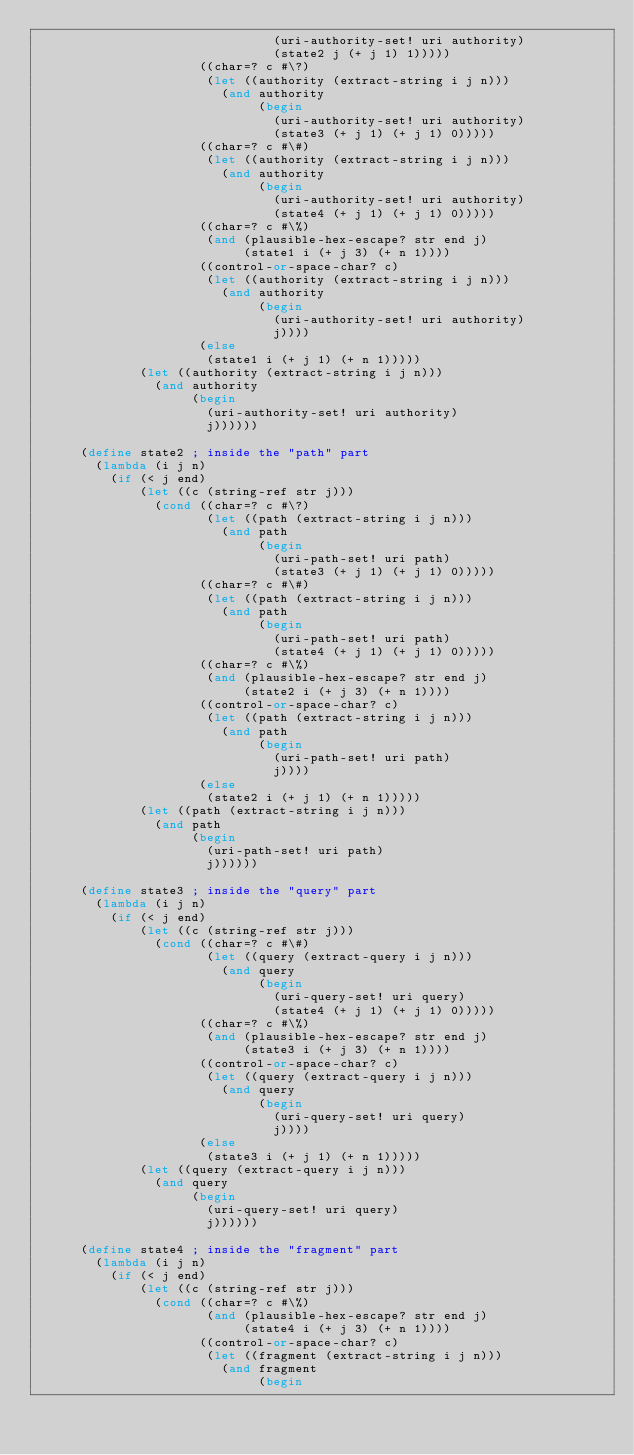Convert code to text. <code><loc_0><loc_0><loc_500><loc_500><_Scheme_>                                (uri-authority-set! uri authority)
                                (state2 j (+ j 1) 1)))))
                      ((char=? c #\?)
                       (let ((authority (extract-string i j n)))
                         (and authority
                              (begin
                                (uri-authority-set! uri authority)
                                (state3 (+ j 1) (+ j 1) 0)))))
                      ((char=? c #\#)
                       (let ((authority (extract-string i j n)))
                         (and authority
                              (begin
                                (uri-authority-set! uri authority)
                                (state4 (+ j 1) (+ j 1) 0)))))
                      ((char=? c #\%)
                       (and (plausible-hex-escape? str end j)
                            (state1 i (+ j 3) (+ n 1))))
                      ((control-or-space-char? c)
                       (let ((authority (extract-string i j n)))
                         (and authority
                              (begin
                                (uri-authority-set! uri authority)
                                j))))
                      (else
                       (state1 i (+ j 1) (+ n 1)))))
              (let ((authority (extract-string i j n)))
                (and authority
                     (begin
                       (uri-authority-set! uri authority)
                       j))))))

      (define state2 ; inside the "path" part
        (lambda (i j n)
          (if (< j end)
              (let ((c (string-ref str j)))
                (cond ((char=? c #\?)
                       (let ((path (extract-string i j n)))
                         (and path
                              (begin
                                (uri-path-set! uri path)
                                (state3 (+ j 1) (+ j 1) 0)))))
                      ((char=? c #\#)
                       (let ((path (extract-string i j n)))
                         (and path
                              (begin
                                (uri-path-set! uri path)
                                (state4 (+ j 1) (+ j 1) 0)))))
                      ((char=? c #\%)
                       (and (plausible-hex-escape? str end j)
                            (state2 i (+ j 3) (+ n 1))))
                      ((control-or-space-char? c)
                       (let ((path (extract-string i j n)))
                         (and path
                              (begin
                                (uri-path-set! uri path)
                                j))))
                      (else
                       (state2 i (+ j 1) (+ n 1)))))
              (let ((path (extract-string i j n)))
                (and path
                     (begin
                       (uri-path-set! uri path)
                       j))))))

      (define state3 ; inside the "query" part
        (lambda (i j n)
          (if (< j end)
              (let ((c (string-ref str j)))
                (cond ((char=? c #\#)
                       (let ((query (extract-query i j n)))
                         (and query
                              (begin
                                (uri-query-set! uri query)
                                (state4 (+ j 1) (+ j 1) 0)))))
                      ((char=? c #\%)
                       (and (plausible-hex-escape? str end j)
                            (state3 i (+ j 3) (+ n 1))))
                      ((control-or-space-char? c)
                       (let ((query (extract-query i j n)))
                         (and query
                              (begin
                                (uri-query-set! uri query)
                                j))))
                      (else
                       (state3 i (+ j 1) (+ n 1)))))
              (let ((query (extract-query i j n)))
                (and query
                     (begin
                       (uri-query-set! uri query)
                       j))))))

      (define state4 ; inside the "fragment" part
        (lambda (i j n)
          (if (< j end)
              (let ((c (string-ref str j)))
                (cond ((char=? c #\%)
                       (and (plausible-hex-escape? str end j)
                            (state4 i (+ j 3) (+ n 1))))
                      ((control-or-space-char? c)
                       (let ((fragment (extract-string i j n)))
                         (and fragment
                              (begin</code> 